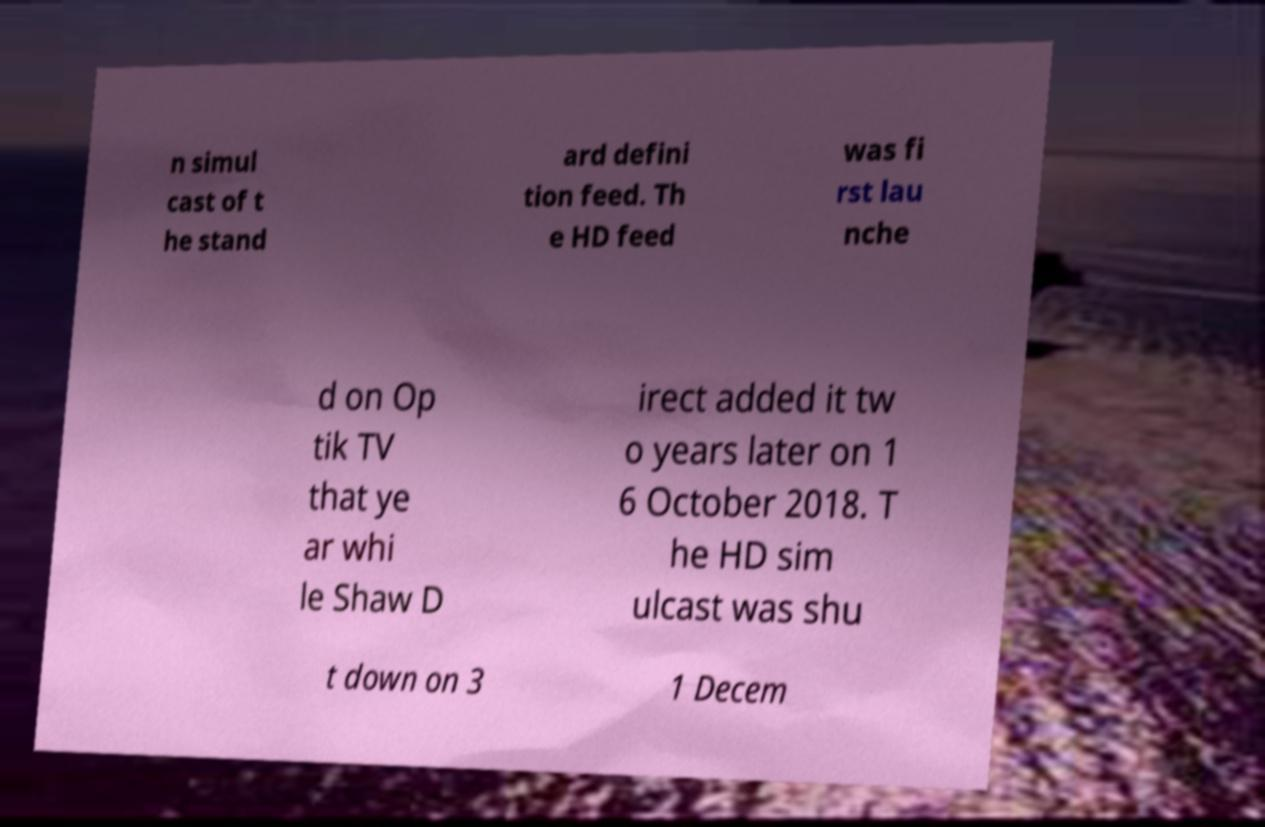For documentation purposes, I need the text within this image transcribed. Could you provide that? n simul cast of t he stand ard defini tion feed. Th e HD feed was fi rst lau nche d on Op tik TV that ye ar whi le Shaw D irect added it tw o years later on 1 6 October 2018. T he HD sim ulcast was shu t down on 3 1 Decem 